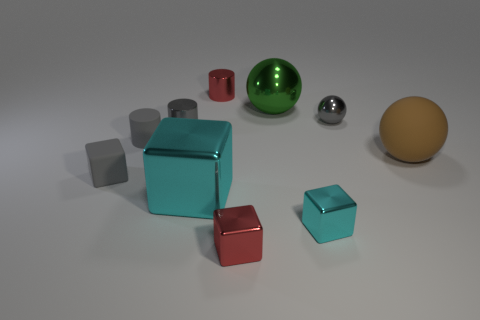Are there more tiny gray metal cylinders that are behind the tiny gray sphere than small metal cylinders?
Ensure brevity in your answer.  No. There is a small red thing to the left of the small red metallic block; what material is it?
Your response must be concise. Metal. There is another metallic object that is the same shape as the green thing; what is its color?
Make the answer very short. Gray. How many large shiny balls are the same color as the tiny rubber cube?
Your answer should be compact. 0. Does the red metal thing that is behind the big cyan thing have the same size as the shiny block that is right of the large green metallic thing?
Your response must be concise. Yes. There is a green shiny sphere; is it the same size as the gray cube that is on the left side of the tiny red metallic cylinder?
Make the answer very short. No. What is the size of the brown sphere?
Your response must be concise. Large. The small ball that is made of the same material as the tiny cyan object is what color?
Make the answer very short. Gray. What number of blue spheres have the same material as the red cube?
Your answer should be very brief. 0. How many objects are gray objects or gray objects that are to the right of the large cyan cube?
Your answer should be very brief. 4. 